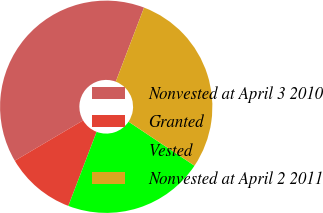Convert chart. <chart><loc_0><loc_0><loc_500><loc_500><pie_chart><fcel>Nonvested at April 3 2010<fcel>Granted<fcel>Vested<fcel>Nonvested at April 2 2011<nl><fcel>39.29%<fcel>10.71%<fcel>21.43%<fcel>28.57%<nl></chart> 